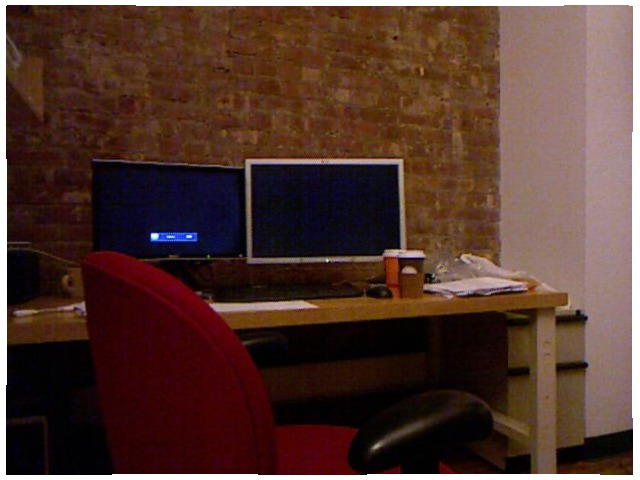<image>
Is there a mug in front of the chair? No. The mug is not in front of the chair. The spatial positioning shows a different relationship between these objects. Is there a screen on the wall? No. The screen is not positioned on the wall. They may be near each other, but the screen is not supported by or resting on top of the wall. Where is the wall in relation to the monitor? Is it behind the monitor? Yes. From this viewpoint, the wall is positioned behind the monitor, with the monitor partially or fully occluding the wall. Where is the computer in relation to the table? Is it under the table? No. The computer is not positioned under the table. The vertical relationship between these objects is different. 